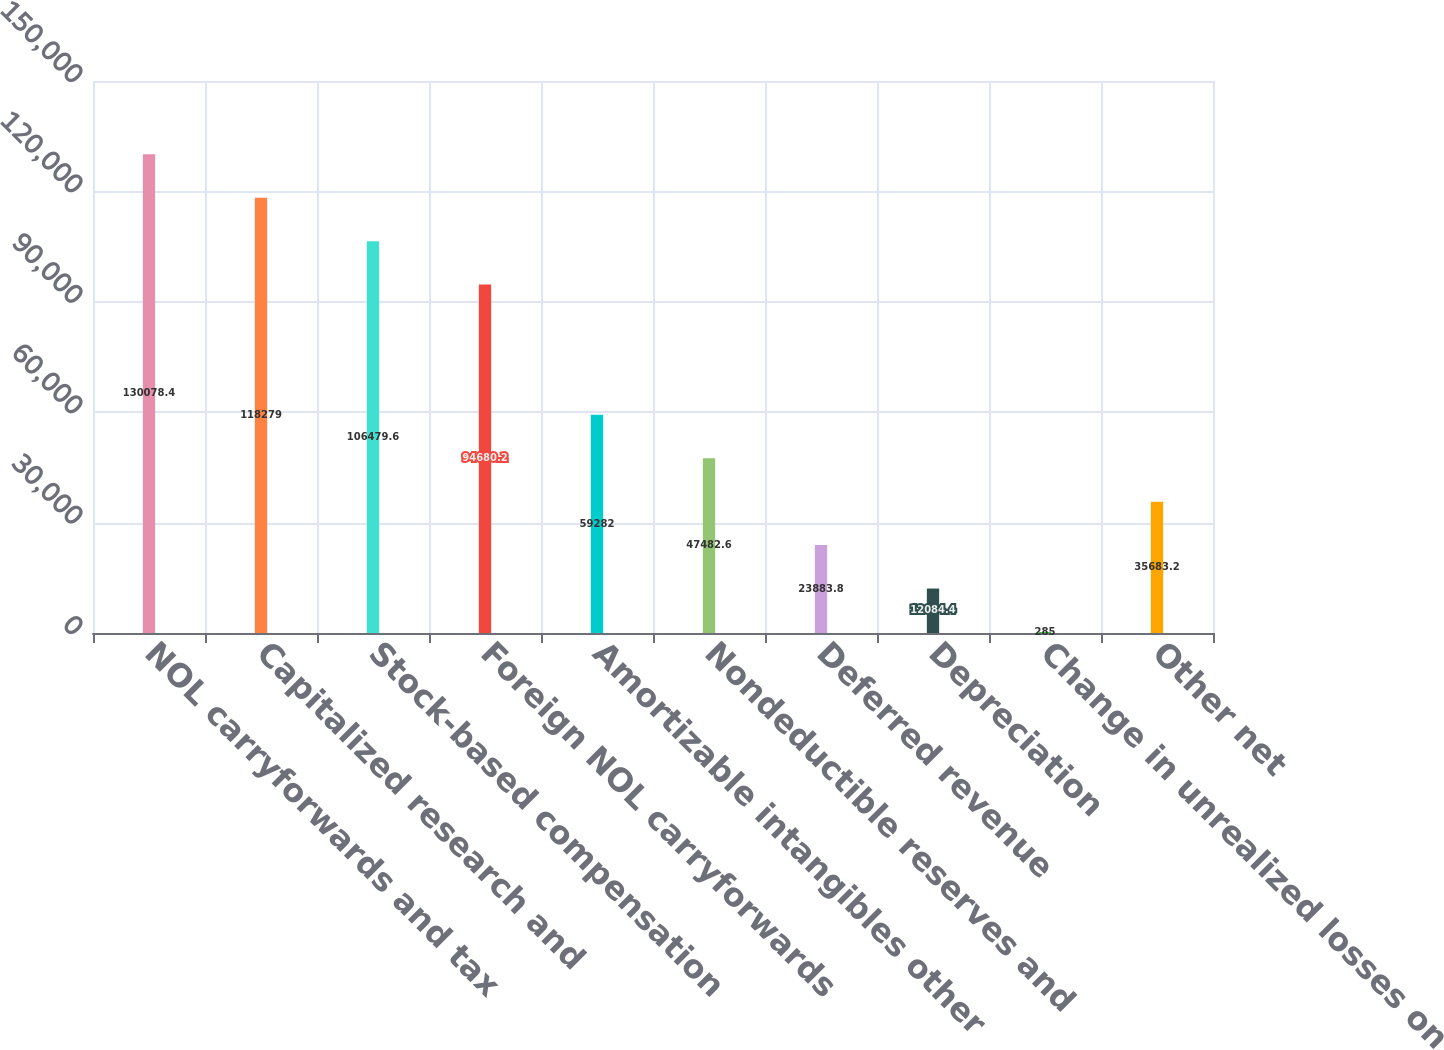Convert chart. <chart><loc_0><loc_0><loc_500><loc_500><bar_chart><fcel>NOL carryforwards and tax<fcel>Capitalized research and<fcel>Stock-based compensation<fcel>Foreign NOL carryforwards<fcel>Amortizable intangibles other<fcel>Nondeductible reserves and<fcel>Deferred revenue<fcel>Depreciation<fcel>Change in unrealized losses on<fcel>Other net<nl><fcel>130078<fcel>118279<fcel>106480<fcel>94680.2<fcel>59282<fcel>47482.6<fcel>23883.8<fcel>12084.4<fcel>285<fcel>35683.2<nl></chart> 